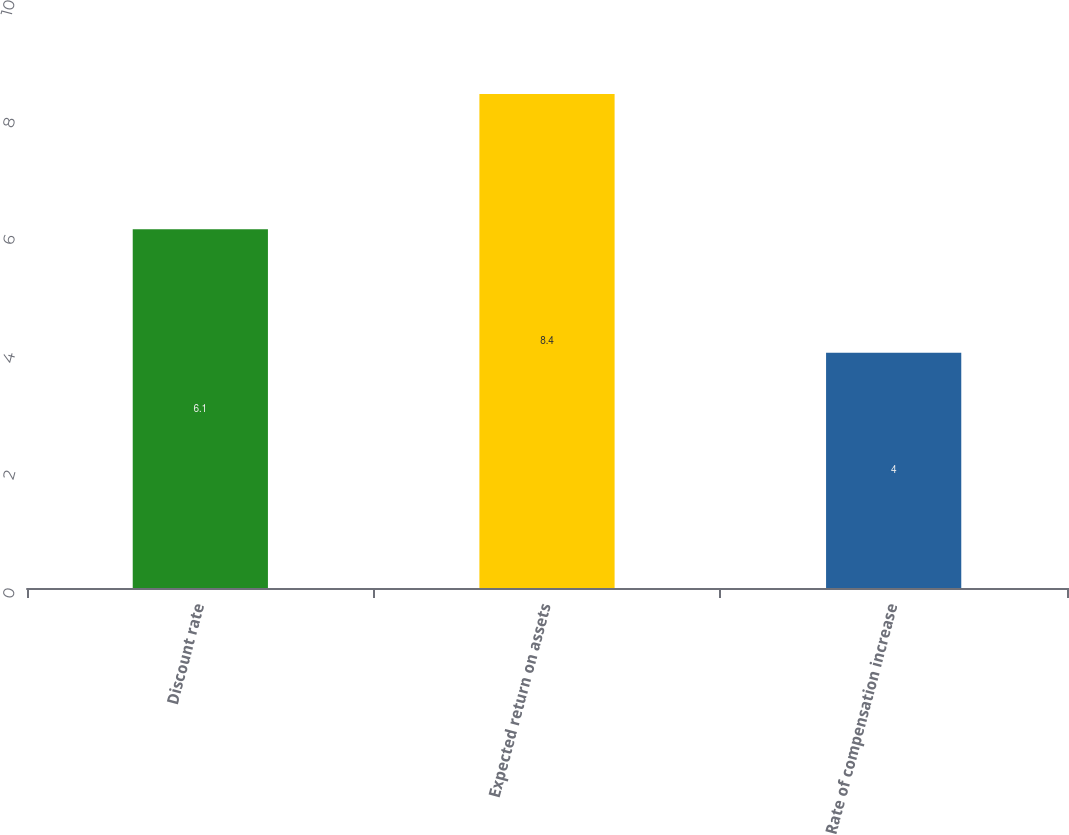Convert chart. <chart><loc_0><loc_0><loc_500><loc_500><bar_chart><fcel>Discount rate<fcel>Expected return on assets<fcel>Rate of compensation increase<nl><fcel>6.1<fcel>8.4<fcel>4<nl></chart> 